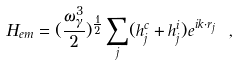Convert formula to latex. <formula><loc_0><loc_0><loc_500><loc_500>H _ { e m } = ( \frac { \omega _ { \gamma } ^ { 3 } } { 2 } ) ^ { \frac { 1 } { 2 } } \sum _ { j } ( h _ { j } ^ { c } + h _ { j } ^ { i } ) e ^ { i { k } \cdot { r } _ { j } } \ ,</formula> 